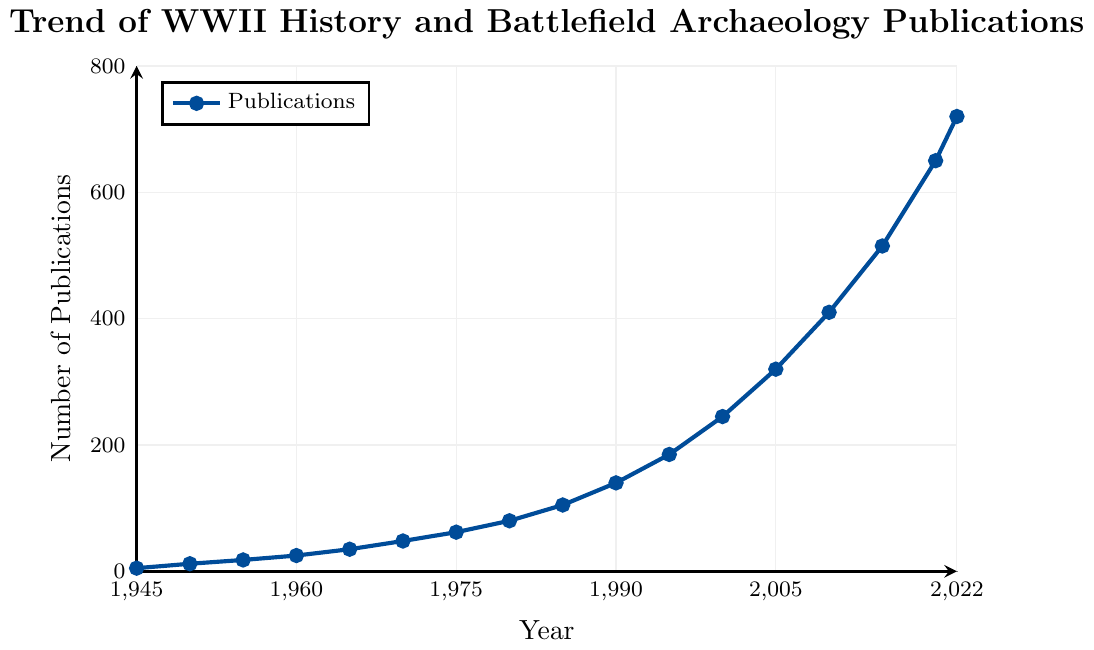What's the number of publications in the year 1975? You need to locate the point on the line that corresponds to the year 1975 on the x-axis and then read the value on the y-axis intersecting this point. It shows 62 publications.
Answer: 62 How many more publications were there in 2022 compared to 1945? First, find the publications in 2022, which is 720, and in 1945, which is 5. Subtract the latter from the former: 720 - 5.
Answer: 715 What is the average number of publications from 1950 to 1965 inclusive? First, find the publications for the years 1950 (12), 1955 (18), 1960 (25), and 1965 (35). Sum these values: 12 + 18 + 25 + 35 = 90. There are 4 years, so divide the sum by 4: 90 / 4.
Answer: 22.5 Which year marks the first time the number of publications exceeded 100? Find the first point on the y-axis that exceeds 100. It corresponds to the year 1985, where the number of publications is 105.
Answer: 1985 By how much did the number of publications change between 2000 and 2005? Locate the publications for the years 2000 (245) and 2005 (320). Subtract the former from the latter: 320 - 245.
Answer: 75 In which period did the number of publications grow the most rapidly? Look at the slope of the line and the number of publications in each period. The period from 2015 (515) to 2020 (650) shows a steep increase (135 publications), while the total number of publications (105) from 1945 to 1985 shows a slower growth over a more extended period. Calculate for other periods similarly and find the steepest slope. The period 2010 (410) to 2015 (515) also shows rapid growth (105 publications). Check which period has the highest increase over the shortest time.
Answer: 2015-2020 What is the difference in the number of publications between 1980 and 1985? Locate the publications for the years 1980 (80) and 1985 (105). Subtract the former from the latter: 105 - 80.
Answer: 25 What is the color of the line representing the trend of publications? Observe the visual attributes of the line on the chart. The line is colored in deep blue.
Answer: Deep blue Which year shows the highest number of publications on the plot? Identify the highest point on the y-axis, which corresponds to the year 2022 with 720 publications.
Answer: 2022 What is the total number of publications from 1945 to 1955? Sum the publications for the years 1945 (5), 1950 (12), and 1955 (18): 5 + 12 + 18.
Answer: 35 